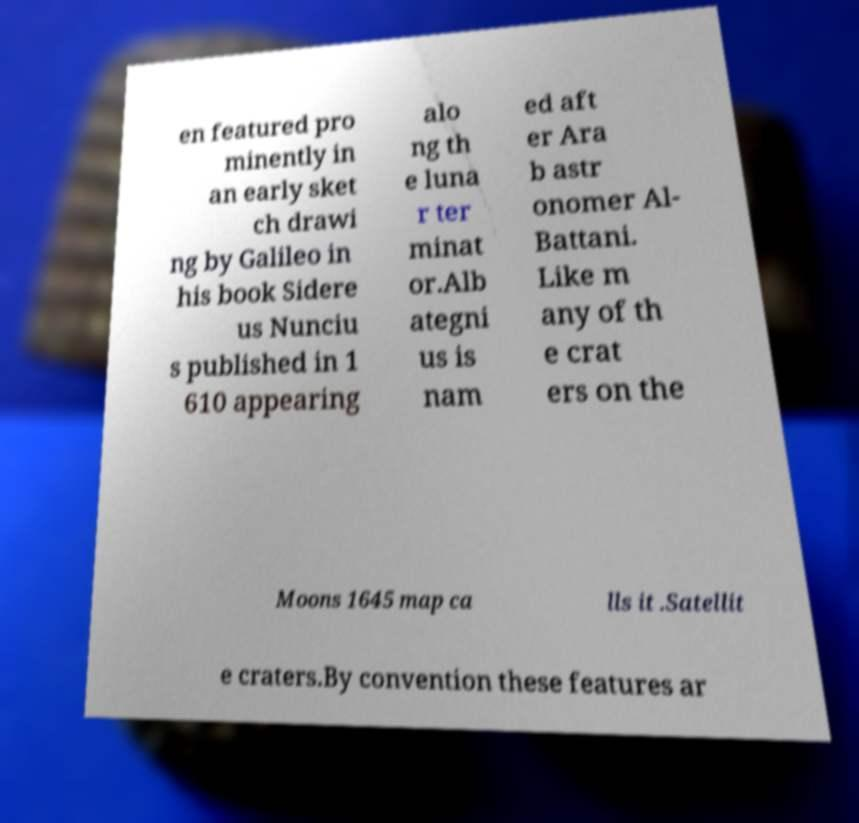Please identify and transcribe the text found in this image. en featured pro minently in an early sket ch drawi ng by Galileo in his book Sidere us Nunciu s published in 1 610 appearing alo ng th e luna r ter minat or.Alb ategni us is nam ed aft er Ara b astr onomer Al- Battani. Like m any of th e crat ers on the Moons 1645 map ca lls it .Satellit e craters.By convention these features ar 